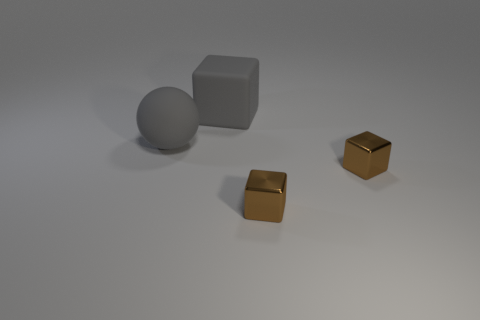Add 2 large gray blocks. How many objects exist? 6 Subtract all blocks. How many objects are left? 1 Add 1 small brown metal blocks. How many small brown metal blocks exist? 3 Subtract 0 yellow cylinders. How many objects are left? 4 Subtract all gray matte cubes. Subtract all rubber things. How many objects are left? 1 Add 1 gray rubber spheres. How many gray rubber spheres are left? 2 